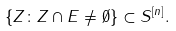Convert formula to latex. <formula><loc_0><loc_0><loc_500><loc_500>\{ Z \colon Z \cap E \neq \emptyset \} \subset S ^ { [ n ] } .</formula> 